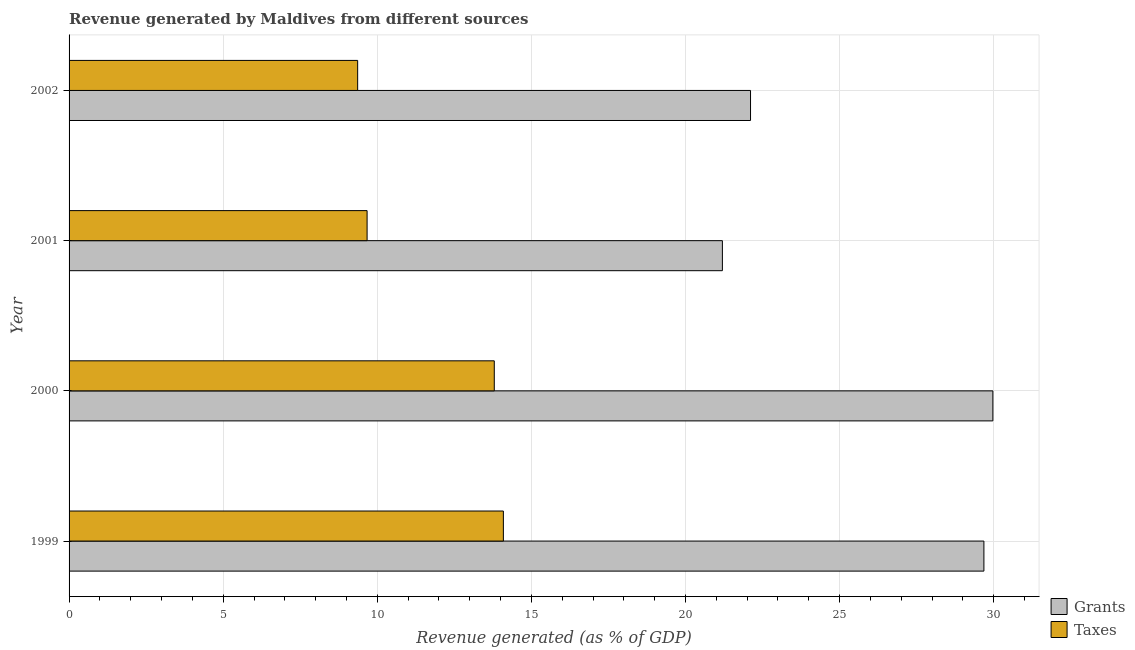Are the number of bars per tick equal to the number of legend labels?
Provide a short and direct response. Yes. What is the label of the 3rd group of bars from the top?
Provide a short and direct response. 2000. In how many cases, is the number of bars for a given year not equal to the number of legend labels?
Your answer should be very brief. 0. What is the revenue generated by grants in 2002?
Provide a succinct answer. 22.11. Across all years, what is the maximum revenue generated by grants?
Make the answer very short. 29.97. Across all years, what is the minimum revenue generated by taxes?
Keep it short and to the point. 9.36. In which year was the revenue generated by taxes minimum?
Provide a short and direct response. 2002. What is the total revenue generated by taxes in the graph?
Your answer should be compact. 46.92. What is the difference between the revenue generated by grants in 2001 and that in 2002?
Provide a succinct answer. -0.91. What is the difference between the revenue generated by taxes in 2002 and the revenue generated by grants in 2000?
Keep it short and to the point. -20.61. What is the average revenue generated by grants per year?
Keep it short and to the point. 25.74. In the year 1999, what is the difference between the revenue generated by taxes and revenue generated by grants?
Make the answer very short. -15.59. What is the ratio of the revenue generated by taxes in 1999 to that in 2001?
Give a very brief answer. 1.46. What is the difference between the highest and the second highest revenue generated by grants?
Your answer should be compact. 0.29. What is the difference between the highest and the lowest revenue generated by grants?
Your answer should be compact. 8.78. What does the 2nd bar from the top in 2000 represents?
Your answer should be very brief. Grants. What does the 1st bar from the bottom in 2001 represents?
Your answer should be compact. Grants. How many years are there in the graph?
Offer a very short reply. 4. What is the difference between two consecutive major ticks on the X-axis?
Your response must be concise. 5. Does the graph contain any zero values?
Ensure brevity in your answer.  No. What is the title of the graph?
Offer a terse response. Revenue generated by Maldives from different sources. Does "Investments" appear as one of the legend labels in the graph?
Your answer should be compact. No. What is the label or title of the X-axis?
Your response must be concise. Revenue generated (as % of GDP). What is the label or title of the Y-axis?
Provide a succinct answer. Year. What is the Revenue generated (as % of GDP) of Grants in 1999?
Offer a terse response. 29.68. What is the Revenue generated (as % of GDP) of Taxes in 1999?
Ensure brevity in your answer.  14.09. What is the Revenue generated (as % of GDP) in Grants in 2000?
Keep it short and to the point. 29.97. What is the Revenue generated (as % of GDP) of Taxes in 2000?
Keep it short and to the point. 13.8. What is the Revenue generated (as % of GDP) of Grants in 2001?
Ensure brevity in your answer.  21.2. What is the Revenue generated (as % of GDP) of Taxes in 2001?
Your answer should be compact. 9.67. What is the Revenue generated (as % of GDP) in Grants in 2002?
Keep it short and to the point. 22.11. What is the Revenue generated (as % of GDP) of Taxes in 2002?
Keep it short and to the point. 9.36. Across all years, what is the maximum Revenue generated (as % of GDP) in Grants?
Your response must be concise. 29.97. Across all years, what is the maximum Revenue generated (as % of GDP) in Taxes?
Offer a very short reply. 14.09. Across all years, what is the minimum Revenue generated (as % of GDP) of Grants?
Keep it short and to the point. 21.2. Across all years, what is the minimum Revenue generated (as % of GDP) of Taxes?
Keep it short and to the point. 9.36. What is the total Revenue generated (as % of GDP) in Grants in the graph?
Keep it short and to the point. 102.96. What is the total Revenue generated (as % of GDP) of Taxes in the graph?
Your answer should be compact. 46.92. What is the difference between the Revenue generated (as % of GDP) in Grants in 1999 and that in 2000?
Offer a very short reply. -0.29. What is the difference between the Revenue generated (as % of GDP) in Taxes in 1999 and that in 2000?
Keep it short and to the point. 0.3. What is the difference between the Revenue generated (as % of GDP) of Grants in 1999 and that in 2001?
Your answer should be very brief. 8.49. What is the difference between the Revenue generated (as % of GDP) in Taxes in 1999 and that in 2001?
Provide a succinct answer. 4.42. What is the difference between the Revenue generated (as % of GDP) in Grants in 1999 and that in 2002?
Give a very brief answer. 7.57. What is the difference between the Revenue generated (as % of GDP) in Taxes in 1999 and that in 2002?
Keep it short and to the point. 4.73. What is the difference between the Revenue generated (as % of GDP) of Grants in 2000 and that in 2001?
Provide a succinct answer. 8.78. What is the difference between the Revenue generated (as % of GDP) of Taxes in 2000 and that in 2001?
Make the answer very short. 4.13. What is the difference between the Revenue generated (as % of GDP) in Grants in 2000 and that in 2002?
Your answer should be compact. 7.86. What is the difference between the Revenue generated (as % of GDP) of Taxes in 2000 and that in 2002?
Provide a short and direct response. 4.43. What is the difference between the Revenue generated (as % of GDP) in Grants in 2001 and that in 2002?
Provide a short and direct response. -0.91. What is the difference between the Revenue generated (as % of GDP) of Taxes in 2001 and that in 2002?
Make the answer very short. 0.31. What is the difference between the Revenue generated (as % of GDP) in Grants in 1999 and the Revenue generated (as % of GDP) in Taxes in 2000?
Keep it short and to the point. 15.89. What is the difference between the Revenue generated (as % of GDP) of Grants in 1999 and the Revenue generated (as % of GDP) of Taxes in 2001?
Provide a short and direct response. 20.01. What is the difference between the Revenue generated (as % of GDP) in Grants in 1999 and the Revenue generated (as % of GDP) in Taxes in 2002?
Offer a terse response. 20.32. What is the difference between the Revenue generated (as % of GDP) of Grants in 2000 and the Revenue generated (as % of GDP) of Taxes in 2001?
Your response must be concise. 20.3. What is the difference between the Revenue generated (as % of GDP) in Grants in 2000 and the Revenue generated (as % of GDP) in Taxes in 2002?
Ensure brevity in your answer.  20.61. What is the difference between the Revenue generated (as % of GDP) in Grants in 2001 and the Revenue generated (as % of GDP) in Taxes in 2002?
Provide a succinct answer. 11.83. What is the average Revenue generated (as % of GDP) of Grants per year?
Provide a short and direct response. 25.74. What is the average Revenue generated (as % of GDP) in Taxes per year?
Offer a terse response. 11.73. In the year 1999, what is the difference between the Revenue generated (as % of GDP) of Grants and Revenue generated (as % of GDP) of Taxes?
Make the answer very short. 15.59. In the year 2000, what is the difference between the Revenue generated (as % of GDP) of Grants and Revenue generated (as % of GDP) of Taxes?
Offer a terse response. 16.18. In the year 2001, what is the difference between the Revenue generated (as % of GDP) in Grants and Revenue generated (as % of GDP) in Taxes?
Your answer should be very brief. 11.53. In the year 2002, what is the difference between the Revenue generated (as % of GDP) in Grants and Revenue generated (as % of GDP) in Taxes?
Your answer should be very brief. 12.75. What is the ratio of the Revenue generated (as % of GDP) of Grants in 1999 to that in 2000?
Your response must be concise. 0.99. What is the ratio of the Revenue generated (as % of GDP) in Taxes in 1999 to that in 2000?
Make the answer very short. 1.02. What is the ratio of the Revenue generated (as % of GDP) of Grants in 1999 to that in 2001?
Provide a succinct answer. 1.4. What is the ratio of the Revenue generated (as % of GDP) of Taxes in 1999 to that in 2001?
Provide a succinct answer. 1.46. What is the ratio of the Revenue generated (as % of GDP) in Grants in 1999 to that in 2002?
Provide a succinct answer. 1.34. What is the ratio of the Revenue generated (as % of GDP) in Taxes in 1999 to that in 2002?
Ensure brevity in your answer.  1.5. What is the ratio of the Revenue generated (as % of GDP) of Grants in 2000 to that in 2001?
Provide a short and direct response. 1.41. What is the ratio of the Revenue generated (as % of GDP) of Taxes in 2000 to that in 2001?
Your answer should be compact. 1.43. What is the ratio of the Revenue generated (as % of GDP) of Grants in 2000 to that in 2002?
Your response must be concise. 1.36. What is the ratio of the Revenue generated (as % of GDP) of Taxes in 2000 to that in 2002?
Keep it short and to the point. 1.47. What is the ratio of the Revenue generated (as % of GDP) of Grants in 2001 to that in 2002?
Keep it short and to the point. 0.96. What is the ratio of the Revenue generated (as % of GDP) in Taxes in 2001 to that in 2002?
Give a very brief answer. 1.03. What is the difference between the highest and the second highest Revenue generated (as % of GDP) of Grants?
Offer a terse response. 0.29. What is the difference between the highest and the second highest Revenue generated (as % of GDP) in Taxes?
Provide a succinct answer. 0.3. What is the difference between the highest and the lowest Revenue generated (as % of GDP) in Grants?
Offer a very short reply. 8.78. What is the difference between the highest and the lowest Revenue generated (as % of GDP) of Taxes?
Ensure brevity in your answer.  4.73. 